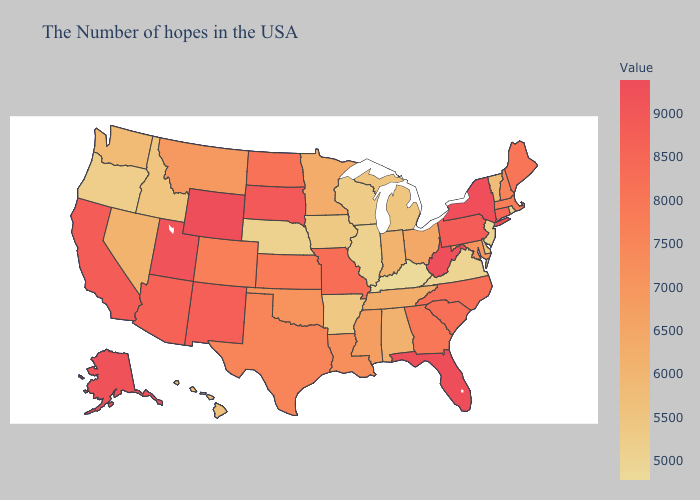Among the states that border California , does Oregon have the highest value?
Answer briefly. No. Does Florida have the lowest value in the USA?
Quick response, please. No. Which states hav the highest value in the Northeast?
Keep it brief. New York. Which states have the lowest value in the South?
Short answer required. Kentucky. Does Wyoming have the lowest value in the USA?
Be succinct. No. Which states hav the highest value in the Northeast?
Write a very short answer. New York. Does Colorado have a lower value than Kentucky?
Write a very short answer. No. Does Vermont have a lower value than Tennessee?
Short answer required. Yes. Which states have the highest value in the USA?
Give a very brief answer. Florida. 